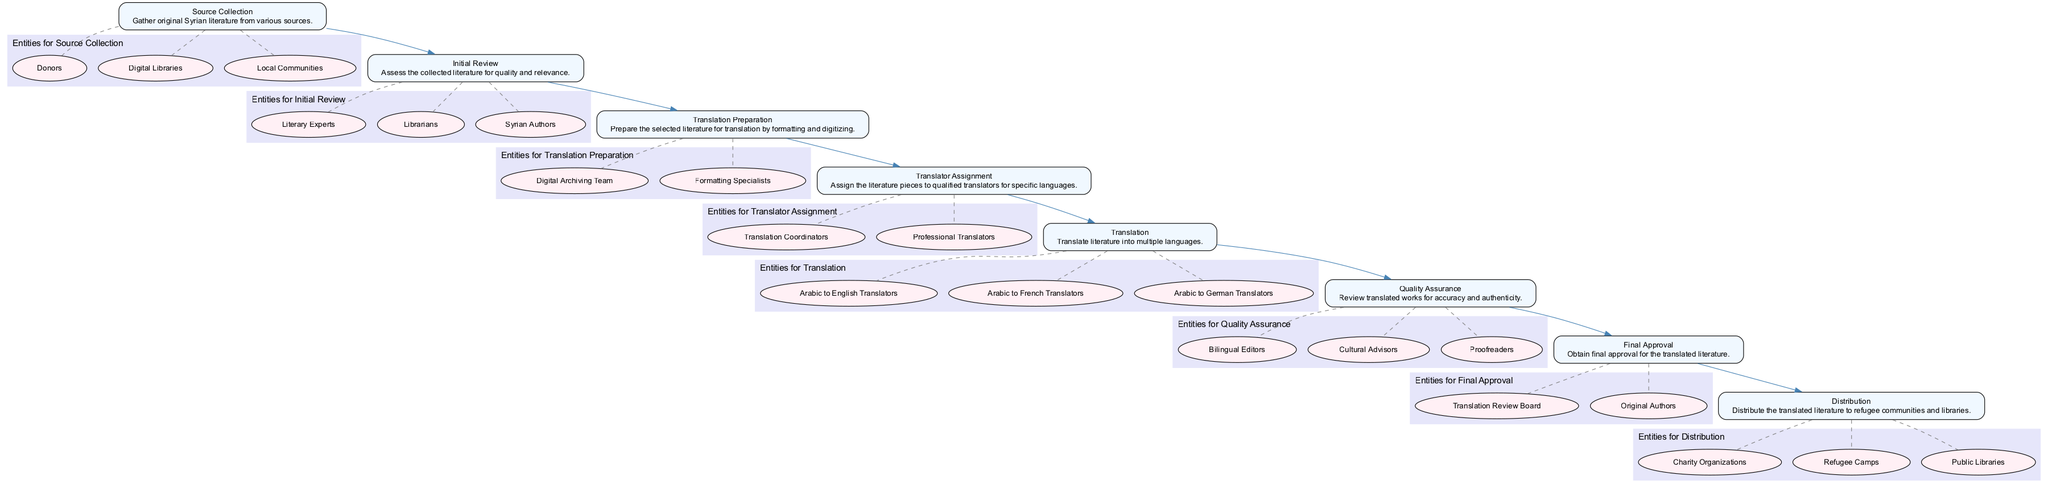What is the first step in the workflow? The workflow begins with the step 'Source Collection', which involves gathering original Syrian literature from various sources. This is indicated as the topmost step in the flowchart.
Answer: Source Collection How many total steps are in the workflow? By counting the listed steps from 'Source Collection' to 'Distribution', there are a total of eight steps in the workflow.
Answer: 8 Who are the entities involved in the 'Translation Preparation' step? Under the 'Translation Preparation' step, the entities mentioned are the 'Digital Archiving Team' and 'Formatting Specialists', which can be found in the subgraph corresponding to that step.
Answer: Digital Archiving Team, Formatting Specialists What is the primary purpose of the 'Quality Assurance' step? The main goal of the 'Quality Assurance' step is to review the translated works for accuracy and authenticity, ensuring they meet quality standards before final approval. This purpose is specified in the description of that step.
Answer: Review for accuracy and authenticity Which step comes after 'Translator Assignment'? The step that follows 'Translator Assignment' in the workflow is 'Translation', as indicated by the arrows connecting the steps sequentially.
Answer: Translation How many entities are associated with the 'Final Approval' step? The 'Final Approval' step has two associated entities: the 'Translation Review Board' and 'Original Authors', which are listed in the subgraph dedicated to this step.
Answer: 2 What are the two main roles involved in the 'Translation' step? In the 'Translation' step, the two main roles specified are 'Arabic to English Translators' and 'Arabic to French Translators', as highlighted in the flowchart's related entities for this step.
Answer: Arabic to English Translators, Arabic to French Translators Which step directly leads to 'Distribution'? The step that directly precedes 'Distribution' is 'Final Approval', indicating that after obtaining the final approval, the literature is ready to be distributed. This connection is shown with a direct arrow pointing from one step to the next.
Answer: Final Approval What is the overall goal of the workflow for translating Syrian literature? The overall goal of the workflow is to translate Syrian literature into multiple languages and distribute it to refugee communities and libraries, as indicated by the final step and its description in the flowchart.
Answer: Translate and distribute to refugee communities and libraries 